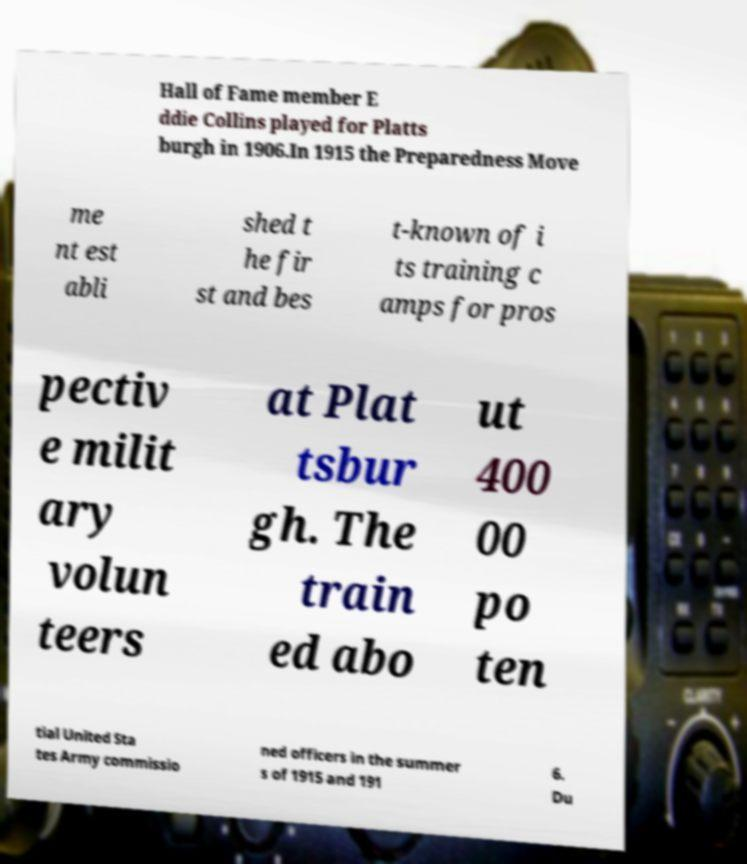Could you assist in decoding the text presented in this image and type it out clearly? Hall of Fame member E ddie Collins played for Platts burgh in 1906.In 1915 the Preparedness Move me nt est abli shed t he fir st and bes t-known of i ts training c amps for pros pectiv e milit ary volun teers at Plat tsbur gh. The train ed abo ut 400 00 po ten tial United Sta tes Army commissio ned officers in the summer s of 1915 and 191 6. Du 